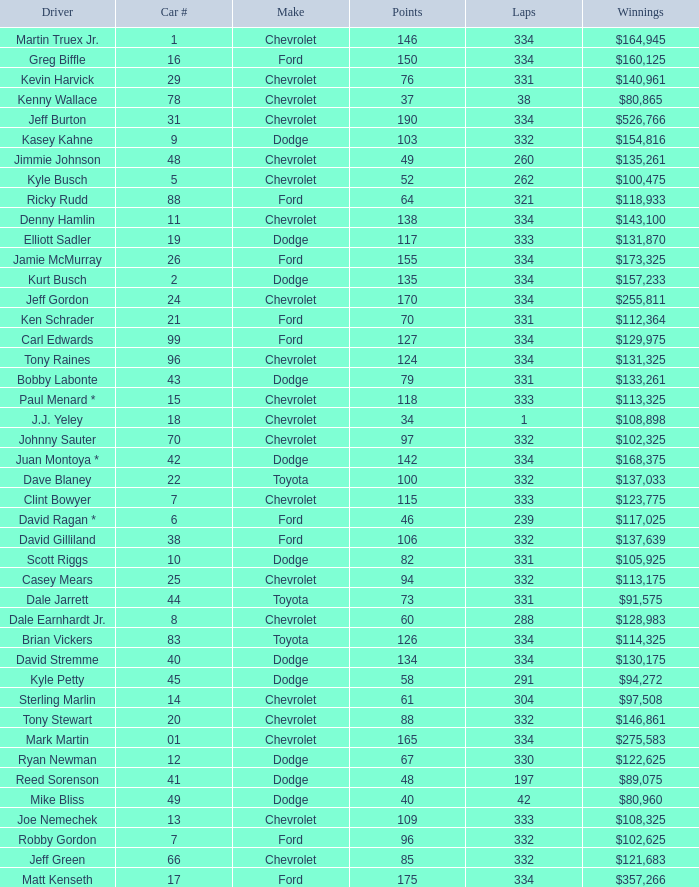How many total laps did the Chevrolet that won $97,508 make? 1.0. 